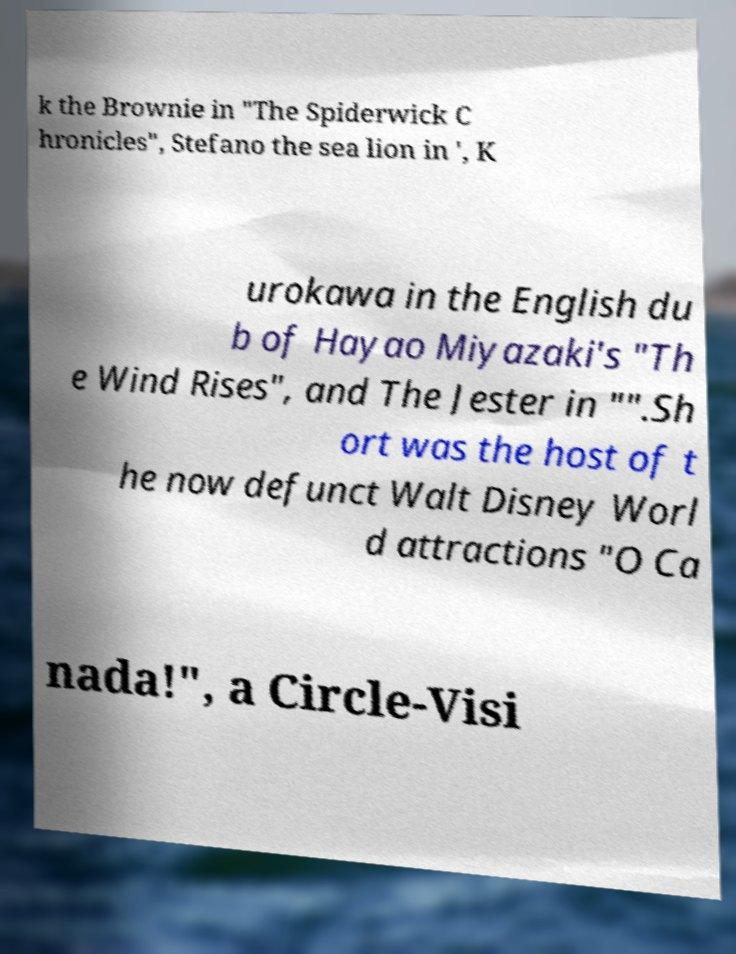There's text embedded in this image that I need extracted. Can you transcribe it verbatim? k the Brownie in "The Spiderwick C hronicles", Stefano the sea lion in ', K urokawa in the English du b of Hayao Miyazaki's "Th e Wind Rises", and The Jester in "".Sh ort was the host of t he now defunct Walt Disney Worl d attractions "O Ca nada!", a Circle-Visi 